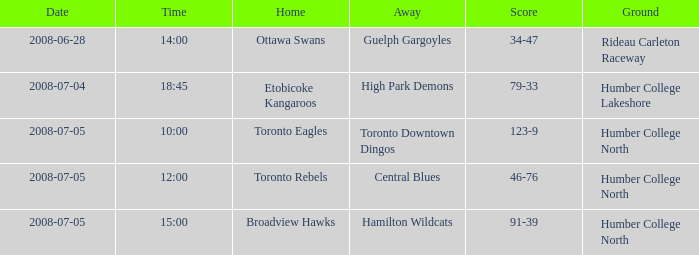Would you be able to parse every entry in this table? {'header': ['Date', 'Time', 'Home', 'Away', 'Score', 'Ground'], 'rows': [['2008-06-28', '14:00', 'Ottawa Swans', 'Guelph Gargoyles', '34-47', 'Rideau Carleton Raceway'], ['2008-07-04', '18:45', 'Etobicoke Kangaroos', 'High Park Demons', '79-33', 'Humber College Lakeshore'], ['2008-07-05', '10:00', 'Toronto Eagles', 'Toronto Downtown Dingos', '123-9', 'Humber College North'], ['2008-07-05', '12:00', 'Toronto Rebels', 'Central Blues', '46-76', 'Humber College North'], ['2008-07-05', '15:00', 'Broadview Hawks', 'Hamilton Wildcats', '91-39', 'Humber College North']]} What is the Score with a Date that is 2008-06-28? 34-47. 